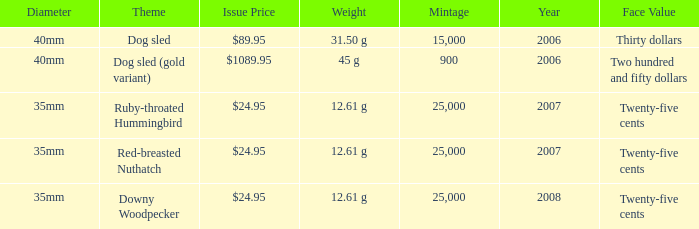What is the Theme of the coin with an Issue Price of $89.95? Dog sled. 